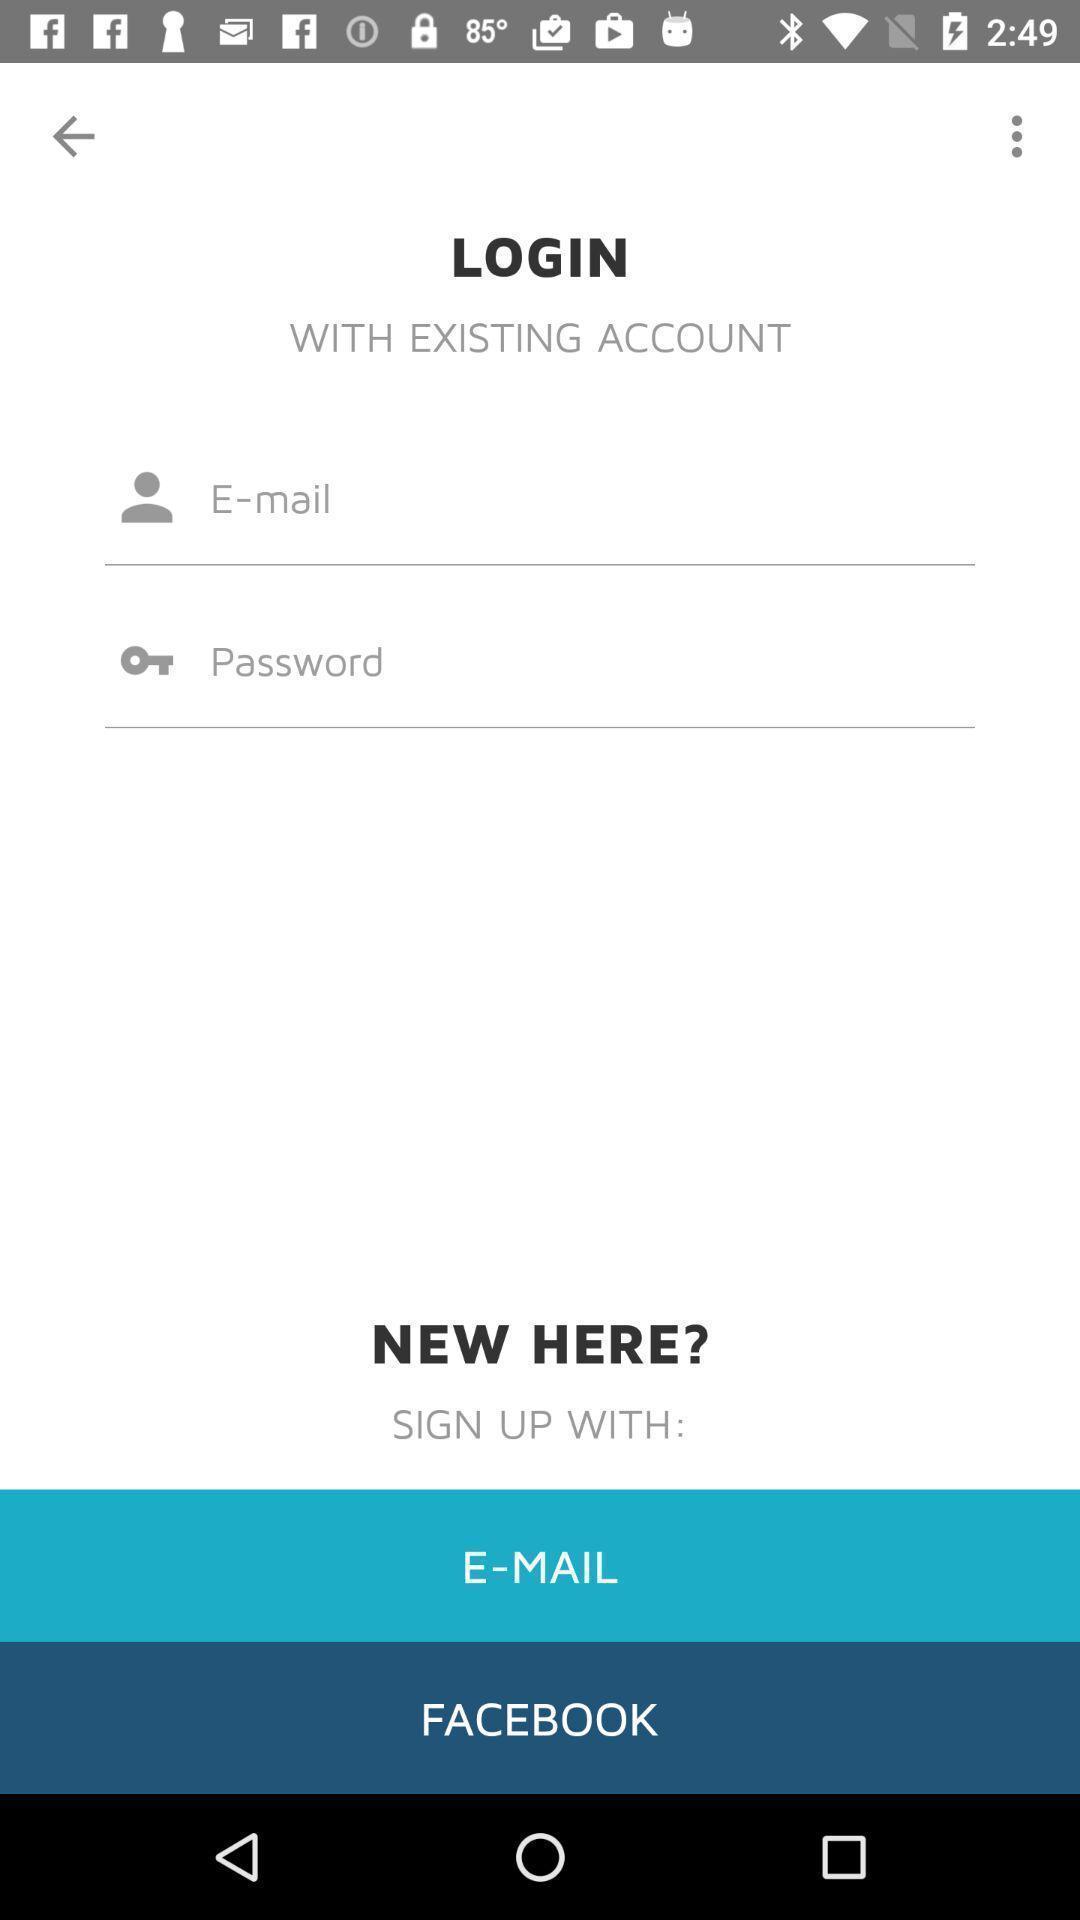Tell me about the visual elements in this screen capture. Page requesting to enter credentials to login on an app. 